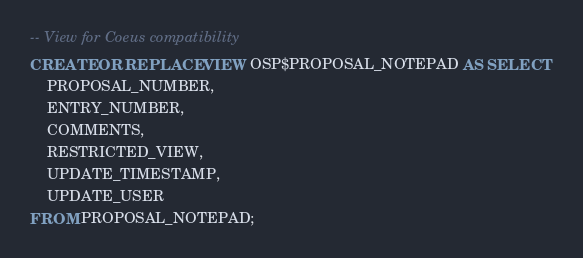Convert code to text. <code><loc_0><loc_0><loc_500><loc_500><_SQL_>-- View for Coeus compatibility 
CREATE OR REPLACE VIEW OSP$PROPOSAL_NOTEPAD AS SELECT 
    PROPOSAL_NUMBER, 
    ENTRY_NUMBER, 
    COMMENTS, 
    RESTRICTED_VIEW, 
    UPDATE_TIMESTAMP, 
    UPDATE_USER
FROM PROPOSAL_NOTEPAD;
</code> 